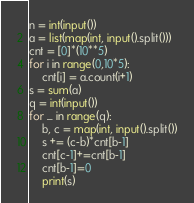<code> <loc_0><loc_0><loc_500><loc_500><_Python_>n = int(input())
a = list(map(int, input().split()))
cnt = [0]*(10**5)
for i in range(0,10*5):
    cnt[i] = a.count(i+1)
s = sum(a)
q = int(input())
for _ in range(q):
    b, c = map(int, input().split())
    s += (c-b)*cnt[b-1]
    cnt[c-1]+=cnt[b-1]
    cnt[b-1]=0
    print(s)</code> 